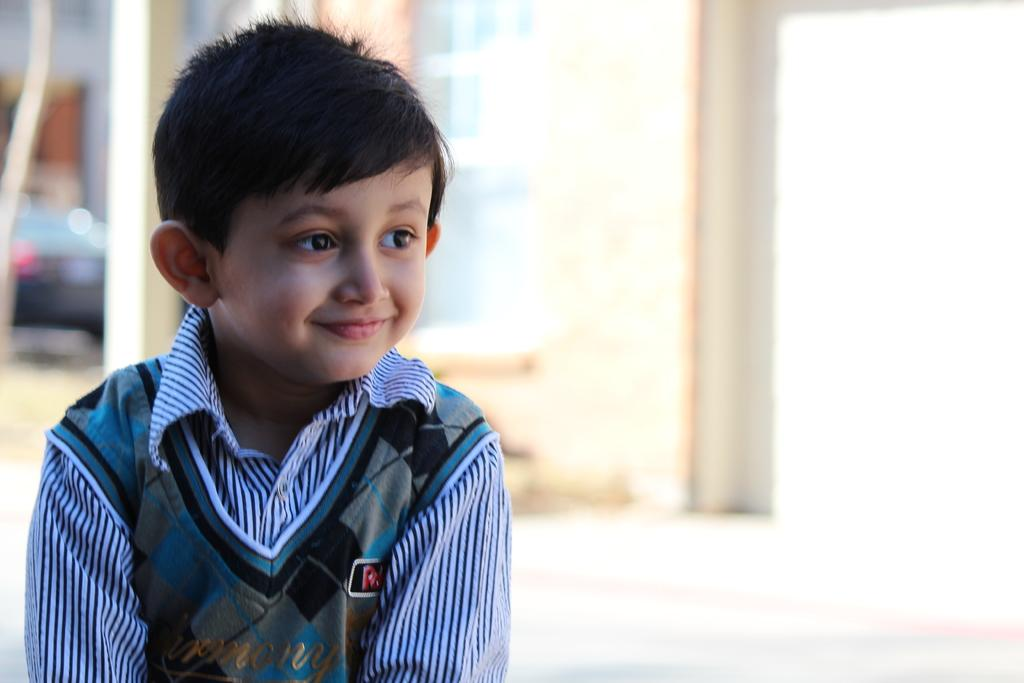Who is present in the image? There is a boy in the image. What is the boy's expression? The boy is smiling. Can you describe the background of the image? The background is blurred in the image. What can be seen on the left side of the image? There is a vehicle on the left side of the image. What structures are present in the image? There is a pillar and a wall in the image. How many spiders are crawling on the wall in the image? There are no spiders visible in the image; only a boy, a vehicle, a pillar, and a wall are present. What type of worm can be seen on the pillar in the image? There are no worms present on the pillar or anywhere else in the image. 